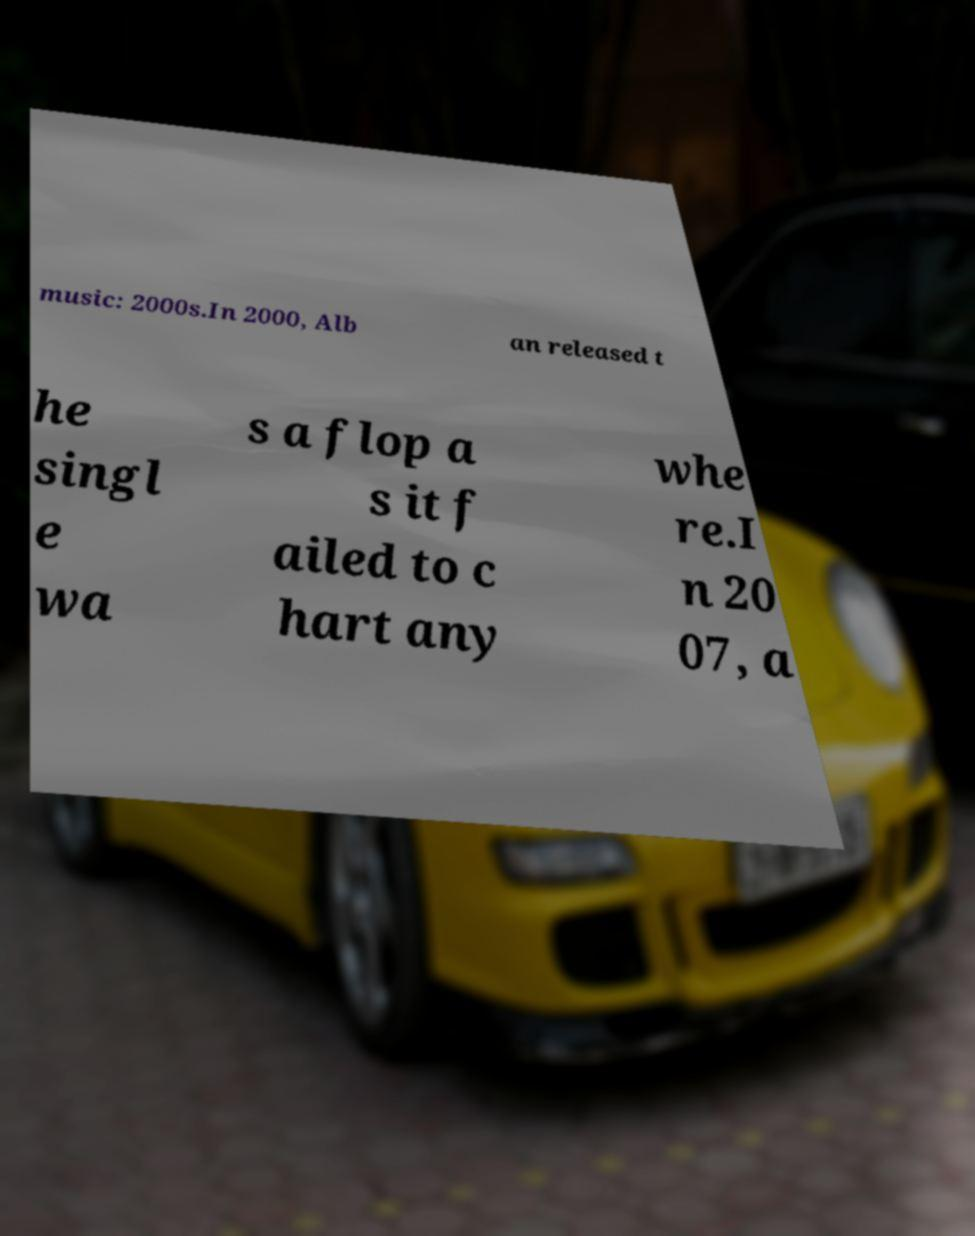For documentation purposes, I need the text within this image transcribed. Could you provide that? music: 2000s.In 2000, Alb an released t he singl e wa s a flop a s it f ailed to c hart any whe re.I n 20 07, a 